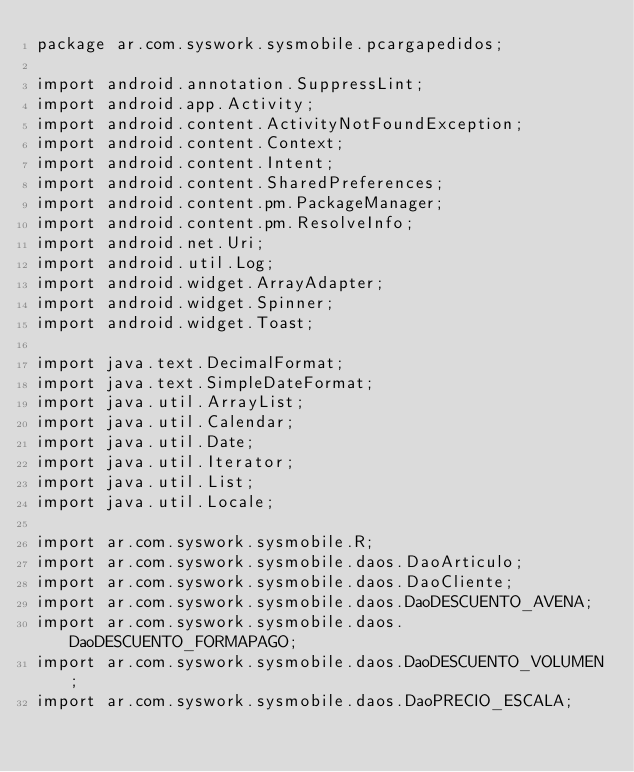<code> <loc_0><loc_0><loc_500><loc_500><_Java_>package ar.com.syswork.sysmobile.pcargapedidos;

import android.annotation.SuppressLint;
import android.app.Activity;
import android.content.ActivityNotFoundException;
import android.content.Context;
import android.content.Intent;
import android.content.SharedPreferences;
import android.content.pm.PackageManager;
import android.content.pm.ResolveInfo;
import android.net.Uri;
import android.util.Log;
import android.widget.ArrayAdapter;
import android.widget.Spinner;
import android.widget.Toast;

import java.text.DecimalFormat;
import java.text.SimpleDateFormat;
import java.util.ArrayList;
import java.util.Calendar;
import java.util.Date;
import java.util.Iterator;
import java.util.List;
import java.util.Locale;

import ar.com.syswork.sysmobile.R;
import ar.com.syswork.sysmobile.daos.DaoArticulo;
import ar.com.syswork.sysmobile.daos.DaoCliente;
import ar.com.syswork.sysmobile.daos.DaoDESCUENTO_AVENA;
import ar.com.syswork.sysmobile.daos.DaoDESCUENTO_FORMAPAGO;
import ar.com.syswork.sysmobile.daos.DaoDESCUENTO_VOLUMEN;
import ar.com.syswork.sysmobile.daos.DaoPRECIO_ESCALA;</code> 